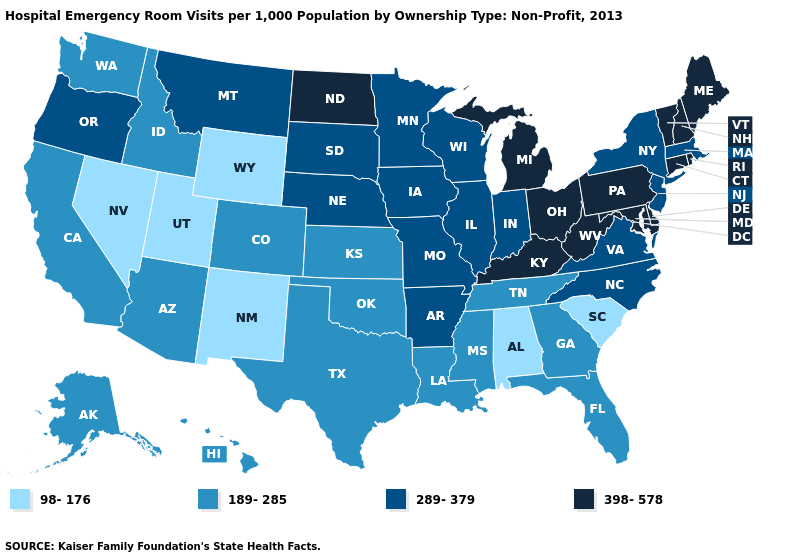What is the value of Florida?
Be succinct. 189-285. What is the value of California?
Quick response, please. 189-285. Name the states that have a value in the range 98-176?
Keep it brief. Alabama, Nevada, New Mexico, South Carolina, Utah, Wyoming. What is the highest value in the South ?
Give a very brief answer. 398-578. Among the states that border Louisiana , does Mississippi have the lowest value?
Answer briefly. Yes. What is the value of Oregon?
Concise answer only. 289-379. Which states have the lowest value in the USA?
Answer briefly. Alabama, Nevada, New Mexico, South Carolina, Utah, Wyoming. What is the value of New Hampshire?
Concise answer only. 398-578. What is the value of Arkansas?
Concise answer only. 289-379. Name the states that have a value in the range 98-176?
Concise answer only. Alabama, Nevada, New Mexico, South Carolina, Utah, Wyoming. Does Montana have the same value as Illinois?
Concise answer only. Yes. Does Pennsylvania have the lowest value in the Northeast?
Short answer required. No. Does Ohio have the same value as Kentucky?
Keep it brief. Yes. What is the value of Ohio?
Write a very short answer. 398-578. What is the lowest value in states that border Wyoming?
Write a very short answer. 98-176. 